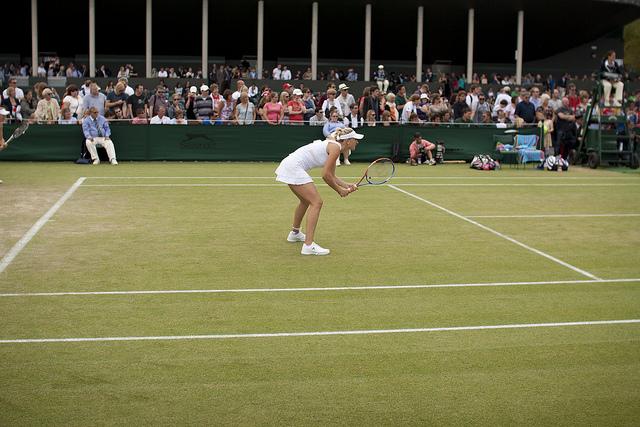What sport is she playing?
Answer briefly. Tennis. Is this woman wearing socks?
Be succinct. Yes. Why is the woman in this position?
Short answer required. Waiting to hit ball. 